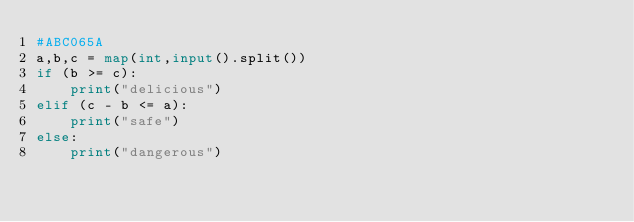Convert code to text. <code><loc_0><loc_0><loc_500><loc_500><_Python_>#ABC065A
a,b,c = map(int,input().split())
if (b >= c):
    print("delicious")
elif (c - b <= a):
    print("safe")
else:
    print("dangerous")</code> 